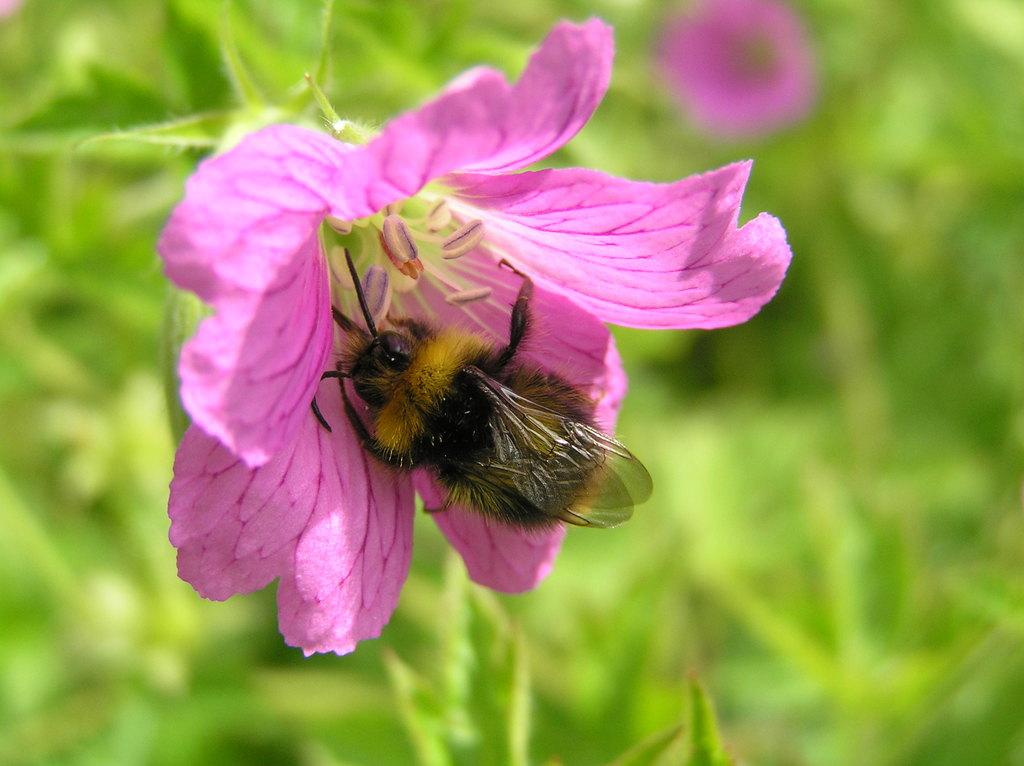What color are the flowers in the image? The flowers in the image are pink. Where are the flowers located? The flowers are on plants. Is there any other living organism present on the flowers? Yes, there is an insect on one of the flowers. Can you describe the background of the image? The background of the image is blurred. What type of scarf is being used to fan the flame in the image? There is no flame or scarf present in the image. 